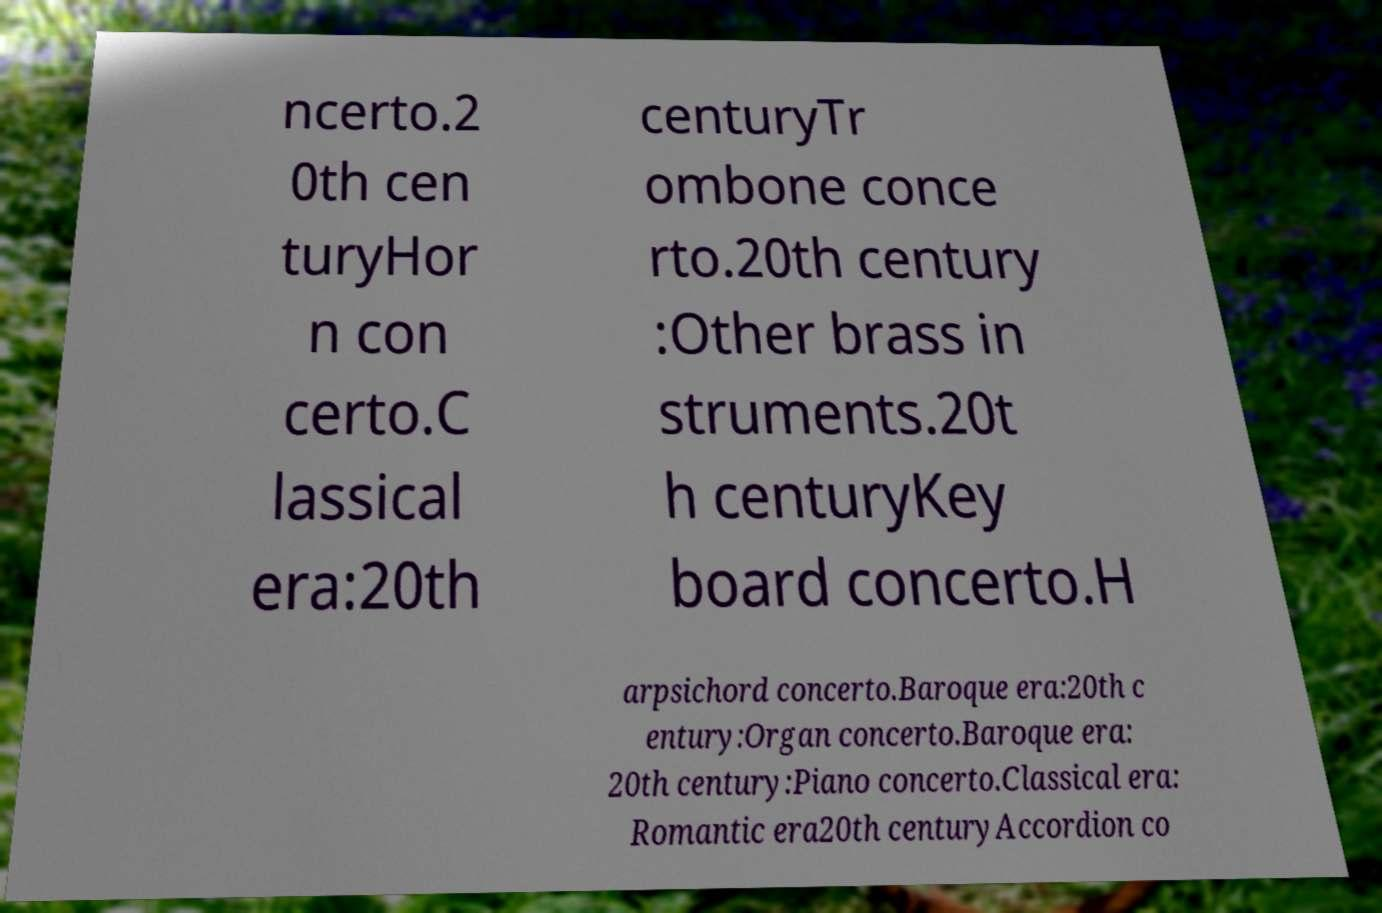Please identify and transcribe the text found in this image. ncerto.2 0th cen turyHor n con certo.C lassical era:20th centuryTr ombone conce rto.20th century :Other brass in struments.20t h centuryKey board concerto.H arpsichord concerto.Baroque era:20th c entury:Organ concerto.Baroque era: 20th century:Piano concerto.Classical era: Romantic era20th centuryAccordion co 